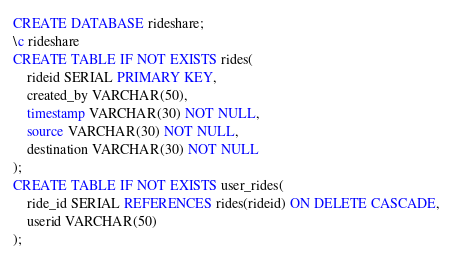<code> <loc_0><loc_0><loc_500><loc_500><_SQL_>CREATE DATABASE rideshare;
\c rideshare
CREATE TABLE IF NOT EXISTS rides(
	rideid SERIAL PRIMARY KEY,
	created_by VARCHAR(50),
	timestamp VARCHAR(30) NOT NULL,
	source VARCHAR(30) NOT NULL,
	destination VARCHAR(30) NOT NULL
);
CREATE TABLE IF NOT EXISTS user_rides(
	ride_id SERIAL REFERENCES rides(rideid) ON DELETE CASCADE,
	userid VARCHAR(50)
);
</code> 